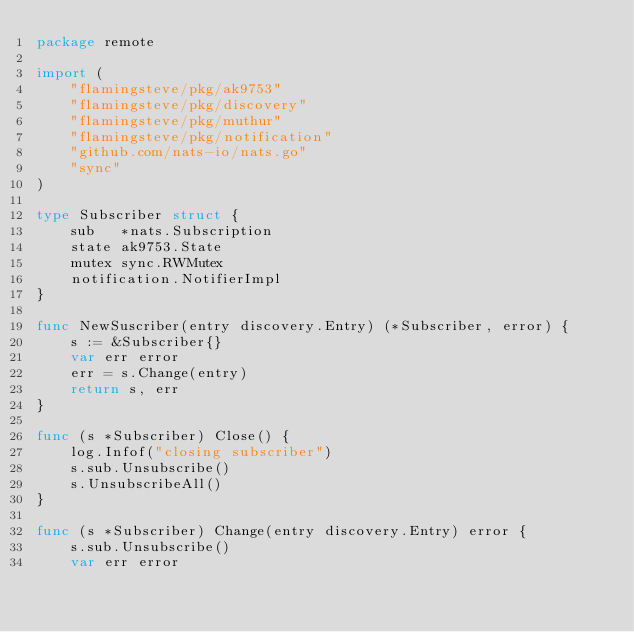Convert code to text. <code><loc_0><loc_0><loc_500><loc_500><_Go_>package remote

import (
	"flamingsteve/pkg/ak9753"
	"flamingsteve/pkg/discovery"
	"flamingsteve/pkg/muthur"
	"flamingsteve/pkg/notification"
	"github.com/nats-io/nats.go"
	"sync"
)

type Subscriber struct {
	sub   *nats.Subscription
	state ak9753.State
	mutex sync.RWMutex
	notification.NotifierImpl
}

func NewSuscriber(entry discovery.Entry) (*Subscriber, error) {
	s := &Subscriber{}
	var err error
	err = s.Change(entry)
	return s, err
}

func (s *Subscriber) Close() {
	log.Infof("closing subscriber")
	s.sub.Unsubscribe()
	s.UnsubscribeAll()
}

func (s *Subscriber) Change(entry discovery.Entry) error {
	s.sub.Unsubscribe()
	var err error</code> 